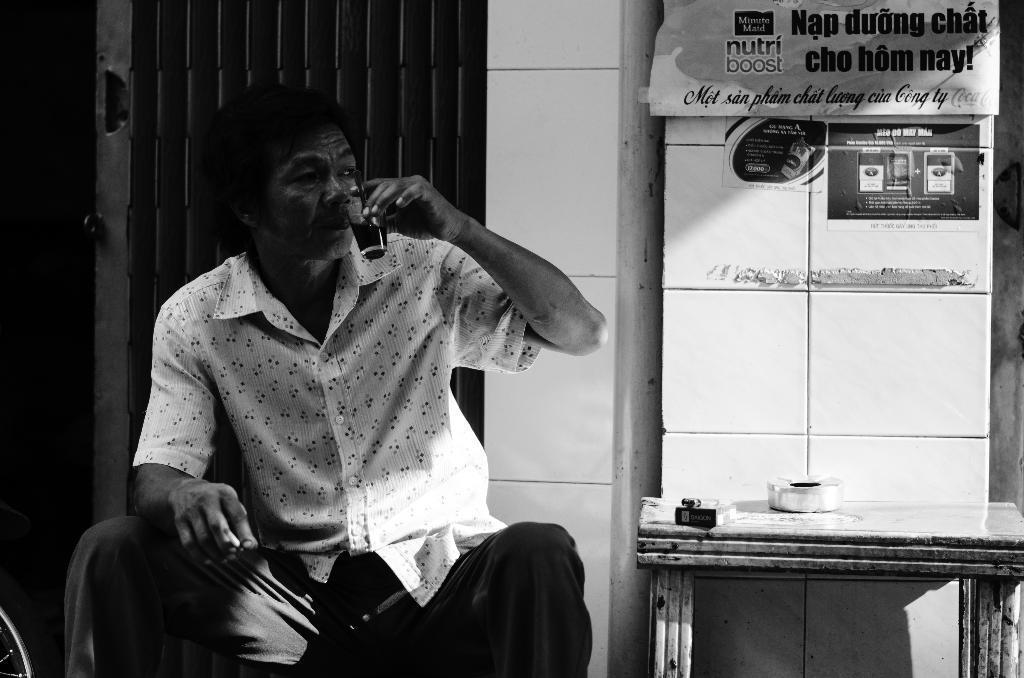Describe this image in one or two sentences. In this image I can see a person is sitting on the chair and holding a glass in hand. On the right I can see a table. In the background I can see a wall and poster. This image is taken may be in a room. 